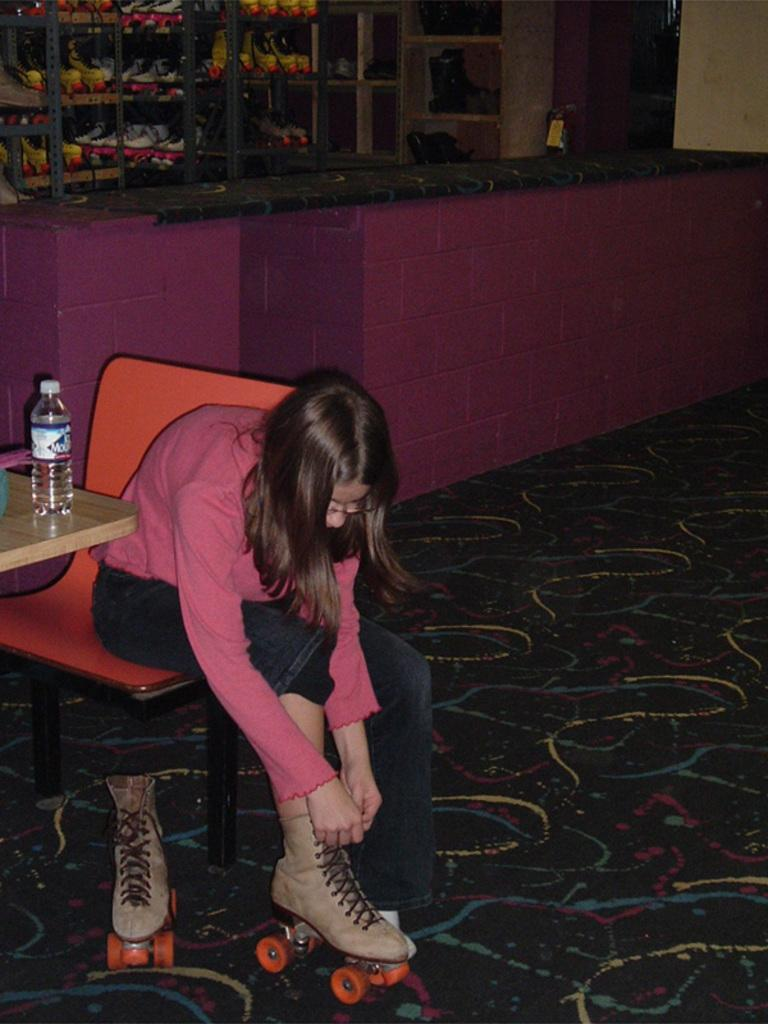What is the person in the image doing? The person is sitting on a chair in the image. What is unique about the person's attire? The person is wearing skating wheels. What object is in front of the person? There is a table in front of the person. What can be found on the table? There is a water bottle on the table. How many cows are visible in the image? There are no cows present in the image. What shape is the tub in the image? There is no tub present in the image. 